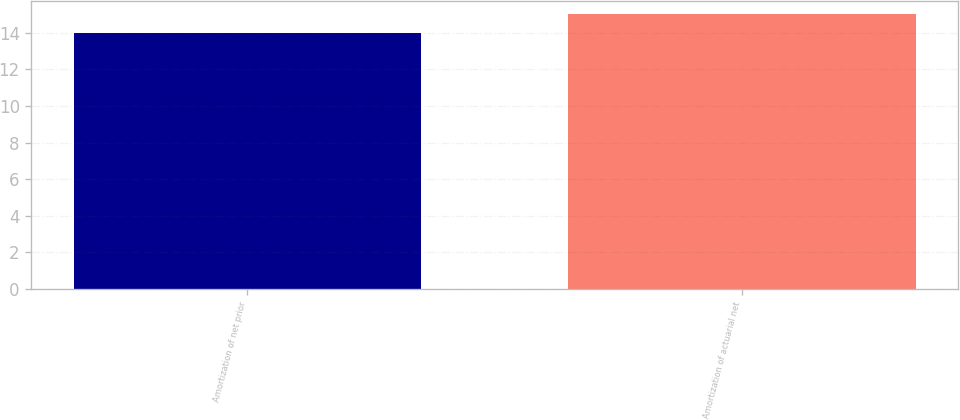Convert chart. <chart><loc_0><loc_0><loc_500><loc_500><bar_chart><fcel>Amortization of net prior<fcel>Amortization of actuarial net<nl><fcel>14<fcel>15<nl></chart> 